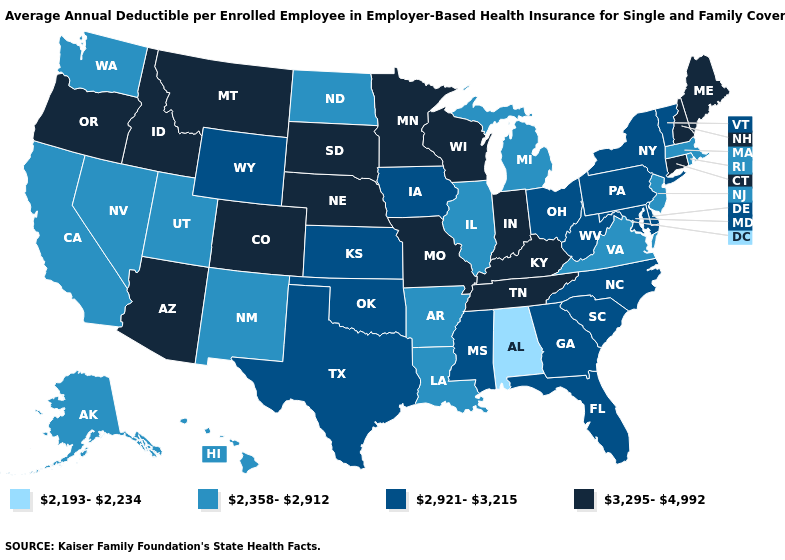What is the value of Rhode Island?
Short answer required. 2,358-2,912. Does North Carolina have a higher value than Wyoming?
Be succinct. No. What is the highest value in the USA?
Concise answer only. 3,295-4,992. Among the states that border Texas , does Arkansas have the lowest value?
Answer briefly. Yes. Name the states that have a value in the range 3,295-4,992?
Concise answer only. Arizona, Colorado, Connecticut, Idaho, Indiana, Kentucky, Maine, Minnesota, Missouri, Montana, Nebraska, New Hampshire, Oregon, South Dakota, Tennessee, Wisconsin. What is the value of Wisconsin?
Short answer required. 3,295-4,992. Does Kansas have a lower value than Ohio?
Keep it brief. No. What is the value of Delaware?
Write a very short answer. 2,921-3,215. What is the highest value in the USA?
Short answer required. 3,295-4,992. Does Louisiana have the highest value in the USA?
Short answer required. No. What is the lowest value in states that border New Jersey?
Short answer required. 2,921-3,215. Name the states that have a value in the range 3,295-4,992?
Concise answer only. Arizona, Colorado, Connecticut, Idaho, Indiana, Kentucky, Maine, Minnesota, Missouri, Montana, Nebraska, New Hampshire, Oregon, South Dakota, Tennessee, Wisconsin. Does the map have missing data?
Keep it brief. No. What is the lowest value in the USA?
Concise answer only. 2,193-2,234. Name the states that have a value in the range 2,193-2,234?
Write a very short answer. Alabama. 